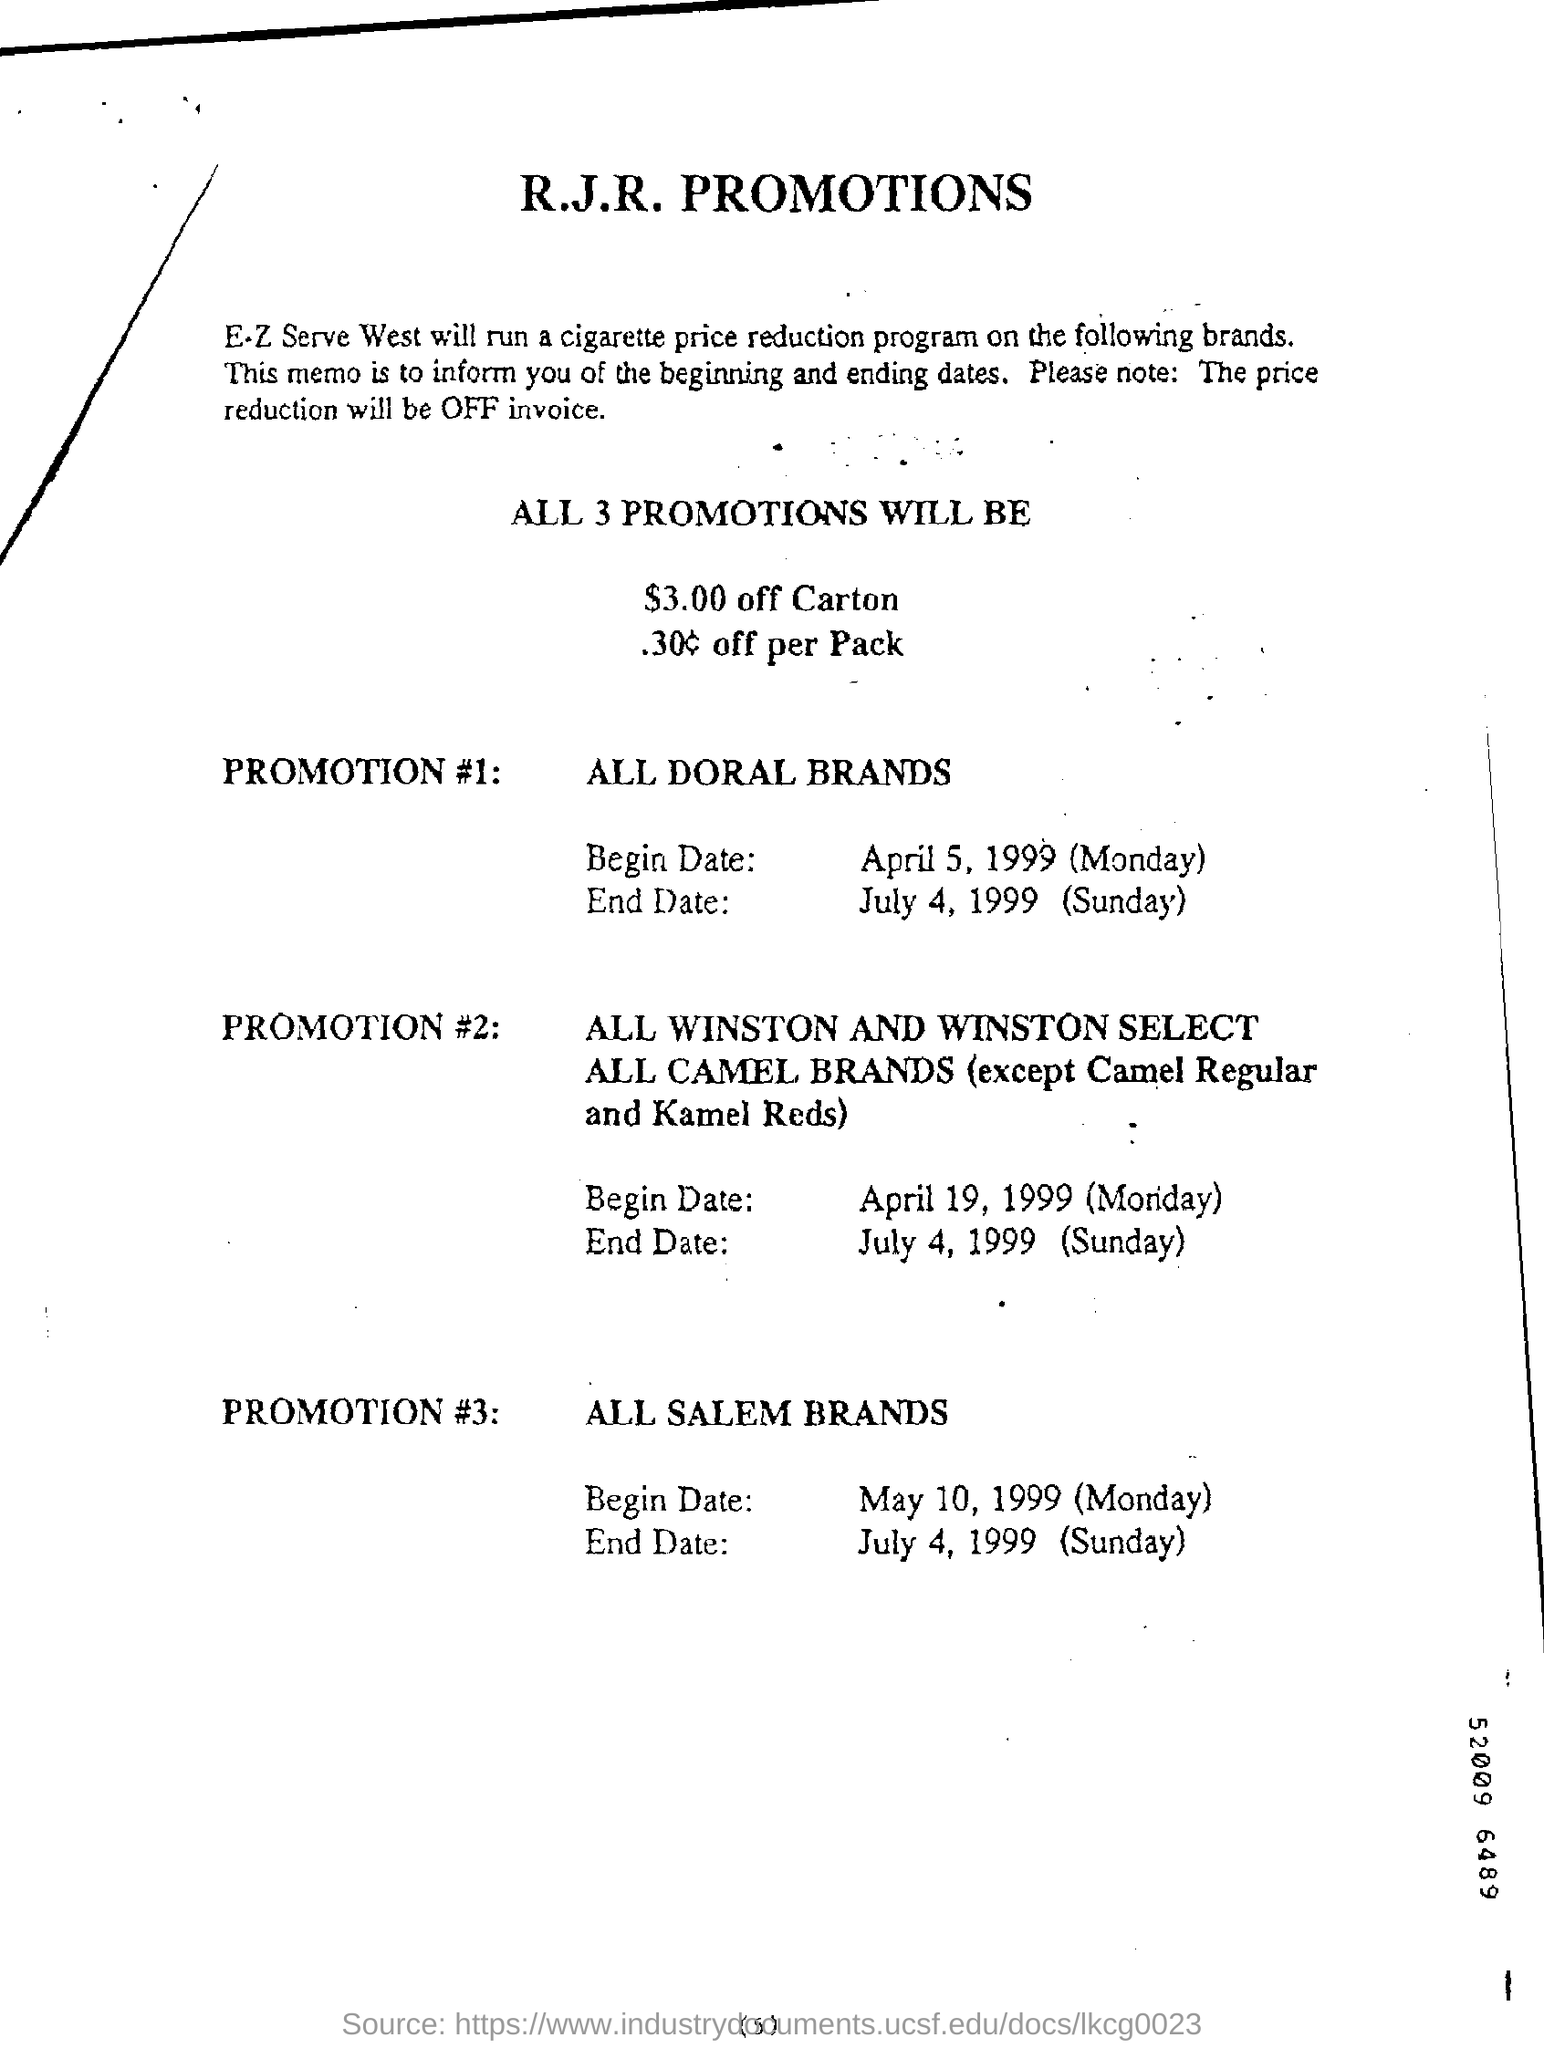Promotion #3 is applicable for which brand?
Your response must be concise. All Salem brands. Promotion #1 is applicable for which brand?
Provide a succinct answer. ALL DORAL BRANDS. 